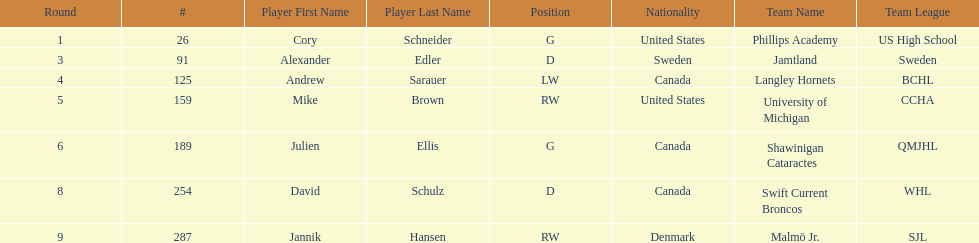How many players were from the united states? 2. 